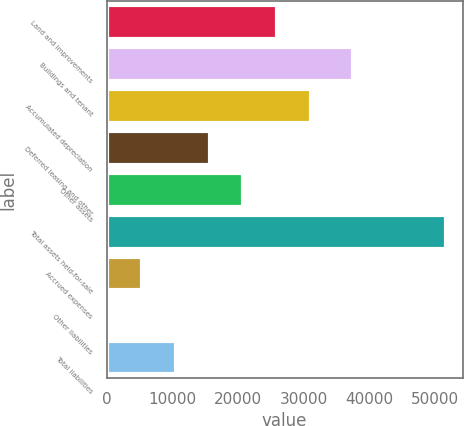<chart> <loc_0><loc_0><loc_500><loc_500><bar_chart><fcel>Land and improvements<fcel>Buildings and tenant<fcel>Accumulated depreciation<fcel>Deferred leasing and other<fcel>Other assets<fcel>Total assets held-for-sale<fcel>Accrued expenses<fcel>Other liabilities<fcel>Total liabilities<nl><fcel>25962.5<fcel>37495<fcel>31095.4<fcel>15696.7<fcel>20829.6<fcel>51627<fcel>5430.9<fcel>298<fcel>10563.8<nl></chart> 